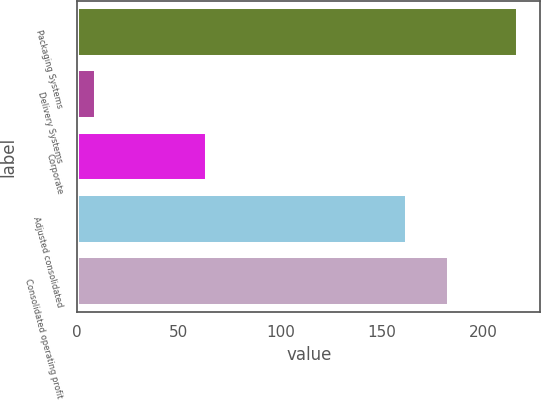Convert chart. <chart><loc_0><loc_0><loc_500><loc_500><bar_chart><fcel>Packaging Systems<fcel>Delivery Systems<fcel>Corporate<fcel>Adjusted consolidated<fcel>Consolidated operating profit<nl><fcel>217<fcel>9.4<fcel>64<fcel>162.4<fcel>183.16<nl></chart> 